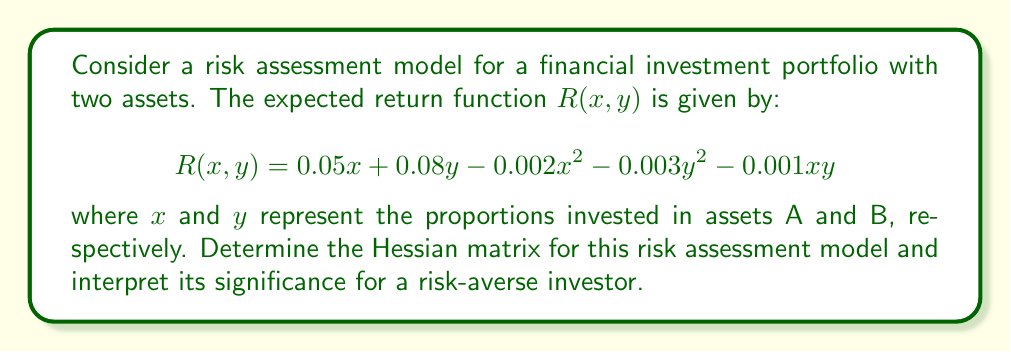Provide a solution to this math problem. To determine the Hessian matrix, we need to follow these steps:

1) The Hessian matrix is a square matrix of second-order partial derivatives. For a function $f(x, y)$, it is defined as:

   $$H = \begin{bmatrix}
   \frac{\partial^2f}{\partial x^2} & \frac{\partial^2f}{\partial x\partial y} \\
   \frac{\partial^2f}{\partial y\partial x} & \frac{\partial^2f}{\partial y^2}
   \end{bmatrix}$$

2) Let's calculate each element of the Hessian matrix:

   a) $\frac{\partial^2R}{\partial x^2}$:
      First derivative: $\frac{\partial R}{\partial x} = 0.05 - 0.004x - 0.001y$
      Second derivative: $\frac{\partial^2R}{\partial x^2} = -0.004$

   b) $\frac{\partial^2R}{\partial y^2}$:
      First derivative: $\frac{\partial R}{\partial y} = 0.08 - 0.006y - 0.001x$
      Second derivative: $\frac{\partial^2R}{\partial y^2} = -0.006$

   c) $\frac{\partial^2R}{\partial x\partial y} = \frac{\partial^2R}{\partial y\partial x} = -0.001$

3) Now we can construct the Hessian matrix:

   $$H = \begin{bmatrix}
   -0.004 & -0.001 \\
   -0.001 & -0.006
   \end{bmatrix}$$

4) Interpretation for a risk-averse investor:
   - The negative values on the main diagonal indicate that the expected return function is concave, which aligns with the risk-averse nature of the investor.
   - The magnitude of these values represents the rate at which marginal returns diminish, with asset B (-0.006) showing a faster rate than asset A (-0.004).
   - The off-diagonal elements (-0.001) represent the interaction between the two assets, indicating a slight negative correlation in their returns.
   - For a risk-averse investor, this Hessian suggests a diversified portfolio with a slight preference for asset A might be optimal to balance risk and return.
Answer: $$H = \begin{bmatrix}
-0.004 & -0.001 \\
-0.001 & -0.006
\end{bmatrix}$$ 